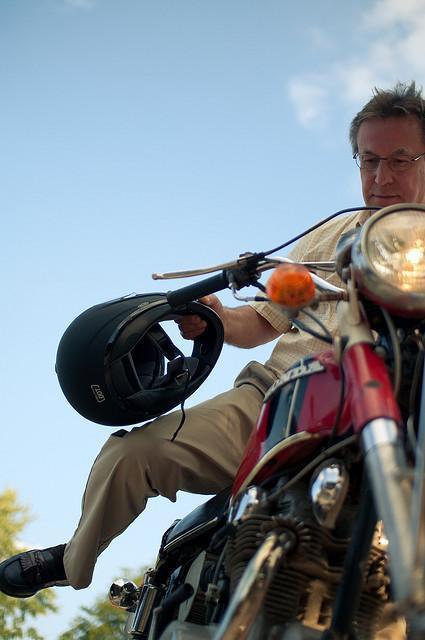How many giraffes are facing to the right?
Give a very brief answer. 0. 